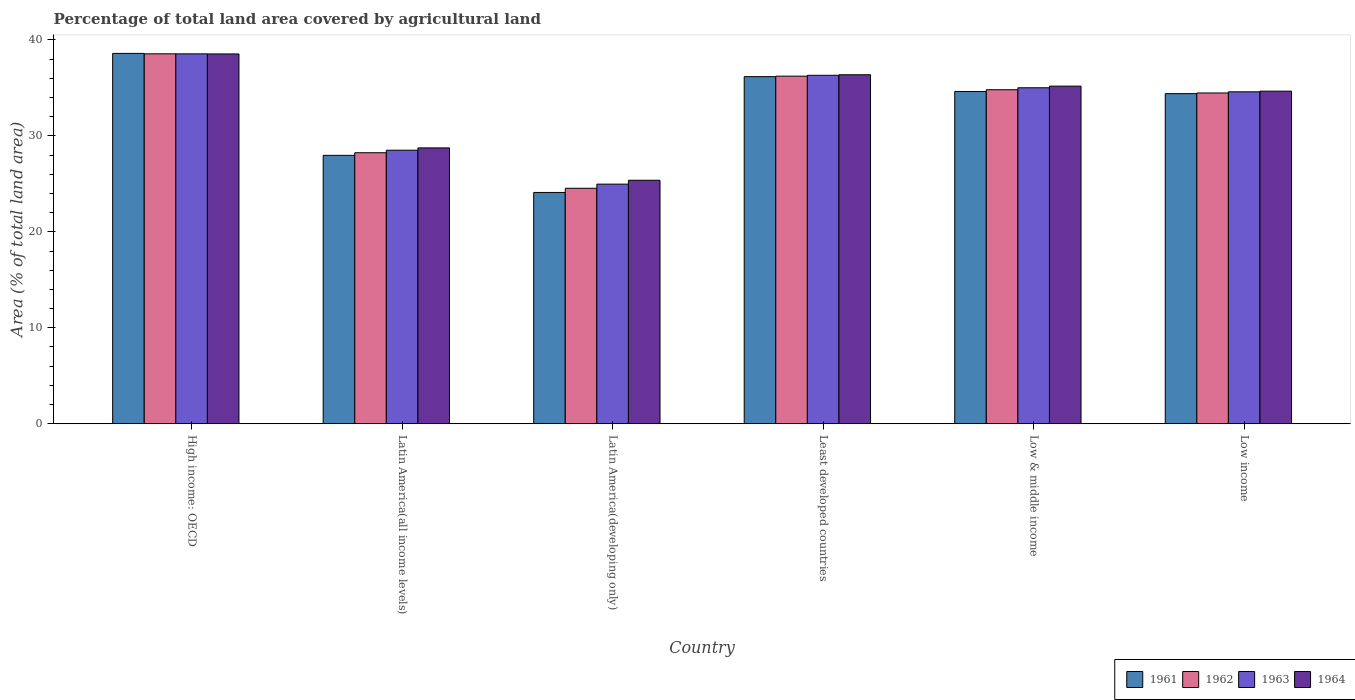Are the number of bars per tick equal to the number of legend labels?
Keep it short and to the point. Yes. Are the number of bars on each tick of the X-axis equal?
Keep it short and to the point. Yes. How many bars are there on the 1st tick from the left?
Provide a short and direct response. 4. How many bars are there on the 5th tick from the right?
Your answer should be compact. 4. What is the label of the 3rd group of bars from the left?
Offer a very short reply. Latin America(developing only). In how many cases, is the number of bars for a given country not equal to the number of legend labels?
Keep it short and to the point. 0. What is the percentage of agricultural land in 1962 in Low income?
Offer a terse response. 34.47. Across all countries, what is the maximum percentage of agricultural land in 1963?
Your answer should be compact. 38.54. Across all countries, what is the minimum percentage of agricultural land in 1964?
Provide a succinct answer. 25.37. In which country was the percentage of agricultural land in 1964 maximum?
Your response must be concise. High income: OECD. In which country was the percentage of agricultural land in 1963 minimum?
Your answer should be compact. Latin America(developing only). What is the total percentage of agricultural land in 1962 in the graph?
Provide a succinct answer. 196.82. What is the difference between the percentage of agricultural land in 1964 in Latin America(all income levels) and that in Low & middle income?
Provide a short and direct response. -6.44. What is the difference between the percentage of agricultural land in 1963 in Latin America(developing only) and the percentage of agricultural land in 1962 in High income: OECD?
Offer a terse response. -13.58. What is the average percentage of agricultural land in 1964 per country?
Make the answer very short. 33.14. What is the difference between the percentage of agricultural land of/in 1964 and percentage of agricultural land of/in 1962 in High income: OECD?
Offer a very short reply. -0.01. What is the ratio of the percentage of agricultural land in 1963 in Latin America(developing only) to that in Low & middle income?
Give a very brief answer. 0.71. Is the percentage of agricultural land in 1964 in High income: OECD less than that in Latin America(developing only)?
Make the answer very short. No. What is the difference between the highest and the second highest percentage of agricultural land in 1964?
Your answer should be very brief. -1.18. What is the difference between the highest and the lowest percentage of agricultural land in 1962?
Your answer should be compact. 14.01. In how many countries, is the percentage of agricultural land in 1961 greater than the average percentage of agricultural land in 1961 taken over all countries?
Offer a terse response. 4. What does the 1st bar from the left in High income: OECD represents?
Ensure brevity in your answer.  1961. What does the 3rd bar from the right in Low & middle income represents?
Your answer should be compact. 1962. How many countries are there in the graph?
Give a very brief answer. 6. Are the values on the major ticks of Y-axis written in scientific E-notation?
Keep it short and to the point. No. Does the graph contain any zero values?
Your answer should be compact. No. Where does the legend appear in the graph?
Your response must be concise. Bottom right. How are the legend labels stacked?
Provide a succinct answer. Horizontal. What is the title of the graph?
Provide a short and direct response. Percentage of total land area covered by agricultural land. What is the label or title of the X-axis?
Your response must be concise. Country. What is the label or title of the Y-axis?
Make the answer very short. Area (% of total land area). What is the Area (% of total land area) of 1961 in High income: OECD?
Offer a very short reply. 38.59. What is the Area (% of total land area) of 1962 in High income: OECD?
Your response must be concise. 38.55. What is the Area (% of total land area) in 1963 in High income: OECD?
Offer a very short reply. 38.54. What is the Area (% of total land area) in 1964 in High income: OECD?
Make the answer very short. 38.53. What is the Area (% of total land area) of 1961 in Latin America(all income levels)?
Ensure brevity in your answer.  27.97. What is the Area (% of total land area) in 1962 in Latin America(all income levels)?
Provide a succinct answer. 28.24. What is the Area (% of total land area) in 1963 in Latin America(all income levels)?
Your answer should be very brief. 28.5. What is the Area (% of total land area) in 1964 in Latin America(all income levels)?
Ensure brevity in your answer.  28.74. What is the Area (% of total land area) of 1961 in Latin America(developing only)?
Make the answer very short. 24.1. What is the Area (% of total land area) of 1962 in Latin America(developing only)?
Your answer should be compact. 24.54. What is the Area (% of total land area) of 1963 in Latin America(developing only)?
Offer a terse response. 24.97. What is the Area (% of total land area) in 1964 in Latin America(developing only)?
Provide a short and direct response. 25.37. What is the Area (% of total land area) of 1961 in Least developed countries?
Make the answer very short. 36.17. What is the Area (% of total land area) of 1962 in Least developed countries?
Offer a terse response. 36.22. What is the Area (% of total land area) in 1963 in Least developed countries?
Provide a succinct answer. 36.31. What is the Area (% of total land area) of 1964 in Least developed countries?
Provide a succinct answer. 36.37. What is the Area (% of total land area) of 1961 in Low & middle income?
Ensure brevity in your answer.  34.62. What is the Area (% of total land area) in 1962 in Low & middle income?
Offer a very short reply. 34.81. What is the Area (% of total land area) in 1963 in Low & middle income?
Provide a short and direct response. 35.01. What is the Area (% of total land area) of 1964 in Low & middle income?
Provide a succinct answer. 35.18. What is the Area (% of total land area) in 1961 in Low income?
Provide a short and direct response. 34.4. What is the Area (% of total land area) in 1962 in Low income?
Keep it short and to the point. 34.47. What is the Area (% of total land area) of 1963 in Low income?
Keep it short and to the point. 34.59. What is the Area (% of total land area) in 1964 in Low income?
Keep it short and to the point. 34.66. Across all countries, what is the maximum Area (% of total land area) in 1961?
Offer a very short reply. 38.59. Across all countries, what is the maximum Area (% of total land area) in 1962?
Give a very brief answer. 38.55. Across all countries, what is the maximum Area (% of total land area) in 1963?
Provide a succinct answer. 38.54. Across all countries, what is the maximum Area (% of total land area) in 1964?
Provide a short and direct response. 38.53. Across all countries, what is the minimum Area (% of total land area) of 1961?
Your answer should be compact. 24.1. Across all countries, what is the minimum Area (% of total land area) of 1962?
Your response must be concise. 24.54. Across all countries, what is the minimum Area (% of total land area) in 1963?
Offer a very short reply. 24.97. Across all countries, what is the minimum Area (% of total land area) of 1964?
Your response must be concise. 25.37. What is the total Area (% of total land area) in 1961 in the graph?
Provide a short and direct response. 195.85. What is the total Area (% of total land area) of 1962 in the graph?
Your answer should be compact. 196.82. What is the total Area (% of total land area) in 1963 in the graph?
Offer a terse response. 197.92. What is the total Area (% of total land area) of 1964 in the graph?
Make the answer very short. 198.85. What is the difference between the Area (% of total land area) of 1961 in High income: OECD and that in Latin America(all income levels)?
Make the answer very short. 10.62. What is the difference between the Area (% of total land area) of 1962 in High income: OECD and that in Latin America(all income levels)?
Ensure brevity in your answer.  10.31. What is the difference between the Area (% of total land area) of 1963 in High income: OECD and that in Latin America(all income levels)?
Provide a short and direct response. 10.04. What is the difference between the Area (% of total land area) of 1964 in High income: OECD and that in Latin America(all income levels)?
Offer a very short reply. 9.79. What is the difference between the Area (% of total land area) of 1961 in High income: OECD and that in Latin America(developing only)?
Provide a succinct answer. 14.49. What is the difference between the Area (% of total land area) in 1962 in High income: OECD and that in Latin America(developing only)?
Ensure brevity in your answer.  14.01. What is the difference between the Area (% of total land area) of 1963 in High income: OECD and that in Latin America(developing only)?
Your answer should be compact. 13.58. What is the difference between the Area (% of total land area) of 1964 in High income: OECD and that in Latin America(developing only)?
Make the answer very short. 13.16. What is the difference between the Area (% of total land area) in 1961 in High income: OECD and that in Least developed countries?
Keep it short and to the point. 2.42. What is the difference between the Area (% of total land area) of 1962 in High income: OECD and that in Least developed countries?
Your answer should be compact. 2.33. What is the difference between the Area (% of total land area) of 1963 in High income: OECD and that in Least developed countries?
Your answer should be very brief. 2.23. What is the difference between the Area (% of total land area) in 1964 in High income: OECD and that in Least developed countries?
Give a very brief answer. 2.17. What is the difference between the Area (% of total land area) in 1961 in High income: OECD and that in Low & middle income?
Give a very brief answer. 3.97. What is the difference between the Area (% of total land area) in 1962 in High income: OECD and that in Low & middle income?
Your response must be concise. 3.74. What is the difference between the Area (% of total land area) of 1963 in High income: OECD and that in Low & middle income?
Provide a succinct answer. 3.53. What is the difference between the Area (% of total land area) in 1964 in High income: OECD and that in Low & middle income?
Offer a very short reply. 3.35. What is the difference between the Area (% of total land area) of 1961 in High income: OECD and that in Low income?
Make the answer very short. 4.19. What is the difference between the Area (% of total land area) of 1962 in High income: OECD and that in Low income?
Make the answer very short. 4.08. What is the difference between the Area (% of total land area) in 1963 in High income: OECD and that in Low income?
Provide a short and direct response. 3.96. What is the difference between the Area (% of total land area) of 1964 in High income: OECD and that in Low income?
Your response must be concise. 3.88. What is the difference between the Area (% of total land area) of 1961 in Latin America(all income levels) and that in Latin America(developing only)?
Offer a terse response. 3.87. What is the difference between the Area (% of total land area) of 1962 in Latin America(all income levels) and that in Latin America(developing only)?
Your answer should be compact. 3.7. What is the difference between the Area (% of total land area) of 1963 in Latin America(all income levels) and that in Latin America(developing only)?
Your response must be concise. 3.53. What is the difference between the Area (% of total land area) of 1964 in Latin America(all income levels) and that in Latin America(developing only)?
Make the answer very short. 3.37. What is the difference between the Area (% of total land area) of 1961 in Latin America(all income levels) and that in Least developed countries?
Give a very brief answer. -8.2. What is the difference between the Area (% of total land area) of 1962 in Latin America(all income levels) and that in Least developed countries?
Your answer should be very brief. -7.98. What is the difference between the Area (% of total land area) of 1963 in Latin America(all income levels) and that in Least developed countries?
Your response must be concise. -7.81. What is the difference between the Area (% of total land area) of 1964 in Latin America(all income levels) and that in Least developed countries?
Provide a succinct answer. -7.62. What is the difference between the Area (% of total land area) in 1961 in Latin America(all income levels) and that in Low & middle income?
Provide a short and direct response. -6.66. What is the difference between the Area (% of total land area) in 1962 in Latin America(all income levels) and that in Low & middle income?
Your answer should be very brief. -6.57. What is the difference between the Area (% of total land area) of 1963 in Latin America(all income levels) and that in Low & middle income?
Offer a very short reply. -6.51. What is the difference between the Area (% of total land area) of 1964 in Latin America(all income levels) and that in Low & middle income?
Provide a succinct answer. -6.44. What is the difference between the Area (% of total land area) of 1961 in Latin America(all income levels) and that in Low income?
Your answer should be very brief. -6.43. What is the difference between the Area (% of total land area) in 1962 in Latin America(all income levels) and that in Low income?
Provide a succinct answer. -6.23. What is the difference between the Area (% of total land area) in 1963 in Latin America(all income levels) and that in Low income?
Provide a succinct answer. -6.08. What is the difference between the Area (% of total land area) in 1964 in Latin America(all income levels) and that in Low income?
Offer a very short reply. -5.91. What is the difference between the Area (% of total land area) in 1961 in Latin America(developing only) and that in Least developed countries?
Provide a succinct answer. -12.07. What is the difference between the Area (% of total land area) of 1962 in Latin America(developing only) and that in Least developed countries?
Provide a succinct answer. -11.68. What is the difference between the Area (% of total land area) in 1963 in Latin America(developing only) and that in Least developed countries?
Keep it short and to the point. -11.34. What is the difference between the Area (% of total land area) in 1964 in Latin America(developing only) and that in Least developed countries?
Make the answer very short. -10.99. What is the difference between the Area (% of total land area) in 1961 in Latin America(developing only) and that in Low & middle income?
Your answer should be very brief. -10.52. What is the difference between the Area (% of total land area) of 1962 in Latin America(developing only) and that in Low & middle income?
Give a very brief answer. -10.27. What is the difference between the Area (% of total land area) of 1963 in Latin America(developing only) and that in Low & middle income?
Your answer should be compact. -10.04. What is the difference between the Area (% of total land area) of 1964 in Latin America(developing only) and that in Low & middle income?
Offer a very short reply. -9.81. What is the difference between the Area (% of total land area) of 1961 in Latin America(developing only) and that in Low income?
Ensure brevity in your answer.  -10.3. What is the difference between the Area (% of total land area) of 1962 in Latin America(developing only) and that in Low income?
Your response must be concise. -9.93. What is the difference between the Area (% of total land area) in 1963 in Latin America(developing only) and that in Low income?
Offer a terse response. -9.62. What is the difference between the Area (% of total land area) in 1964 in Latin America(developing only) and that in Low income?
Offer a terse response. -9.28. What is the difference between the Area (% of total land area) of 1961 in Least developed countries and that in Low & middle income?
Your response must be concise. 1.54. What is the difference between the Area (% of total land area) of 1962 in Least developed countries and that in Low & middle income?
Give a very brief answer. 1.42. What is the difference between the Area (% of total land area) in 1963 in Least developed countries and that in Low & middle income?
Make the answer very short. 1.3. What is the difference between the Area (% of total land area) of 1964 in Least developed countries and that in Low & middle income?
Ensure brevity in your answer.  1.19. What is the difference between the Area (% of total land area) of 1961 in Least developed countries and that in Low income?
Provide a short and direct response. 1.77. What is the difference between the Area (% of total land area) of 1962 in Least developed countries and that in Low income?
Provide a short and direct response. 1.75. What is the difference between the Area (% of total land area) in 1963 in Least developed countries and that in Low income?
Make the answer very short. 1.72. What is the difference between the Area (% of total land area) in 1964 in Least developed countries and that in Low income?
Your answer should be compact. 1.71. What is the difference between the Area (% of total land area) of 1961 in Low & middle income and that in Low income?
Offer a terse response. 0.22. What is the difference between the Area (% of total land area) in 1962 in Low & middle income and that in Low income?
Provide a short and direct response. 0.34. What is the difference between the Area (% of total land area) of 1963 in Low & middle income and that in Low income?
Provide a short and direct response. 0.42. What is the difference between the Area (% of total land area) of 1964 in Low & middle income and that in Low income?
Offer a terse response. 0.53. What is the difference between the Area (% of total land area) of 1961 in High income: OECD and the Area (% of total land area) of 1962 in Latin America(all income levels)?
Your answer should be very brief. 10.35. What is the difference between the Area (% of total land area) of 1961 in High income: OECD and the Area (% of total land area) of 1963 in Latin America(all income levels)?
Provide a succinct answer. 10.09. What is the difference between the Area (% of total land area) of 1961 in High income: OECD and the Area (% of total land area) of 1964 in Latin America(all income levels)?
Offer a terse response. 9.85. What is the difference between the Area (% of total land area) of 1962 in High income: OECD and the Area (% of total land area) of 1963 in Latin America(all income levels)?
Keep it short and to the point. 10.04. What is the difference between the Area (% of total land area) of 1962 in High income: OECD and the Area (% of total land area) of 1964 in Latin America(all income levels)?
Offer a terse response. 9.8. What is the difference between the Area (% of total land area) in 1963 in High income: OECD and the Area (% of total land area) in 1964 in Latin America(all income levels)?
Your answer should be compact. 9.8. What is the difference between the Area (% of total land area) of 1961 in High income: OECD and the Area (% of total land area) of 1962 in Latin America(developing only)?
Your answer should be compact. 14.06. What is the difference between the Area (% of total land area) of 1961 in High income: OECD and the Area (% of total land area) of 1963 in Latin America(developing only)?
Your response must be concise. 13.62. What is the difference between the Area (% of total land area) in 1961 in High income: OECD and the Area (% of total land area) in 1964 in Latin America(developing only)?
Keep it short and to the point. 13.22. What is the difference between the Area (% of total land area) in 1962 in High income: OECD and the Area (% of total land area) in 1963 in Latin America(developing only)?
Provide a short and direct response. 13.58. What is the difference between the Area (% of total land area) of 1962 in High income: OECD and the Area (% of total land area) of 1964 in Latin America(developing only)?
Offer a terse response. 13.17. What is the difference between the Area (% of total land area) in 1963 in High income: OECD and the Area (% of total land area) in 1964 in Latin America(developing only)?
Ensure brevity in your answer.  13.17. What is the difference between the Area (% of total land area) in 1961 in High income: OECD and the Area (% of total land area) in 1962 in Least developed countries?
Offer a very short reply. 2.37. What is the difference between the Area (% of total land area) in 1961 in High income: OECD and the Area (% of total land area) in 1963 in Least developed countries?
Your answer should be very brief. 2.28. What is the difference between the Area (% of total land area) in 1961 in High income: OECD and the Area (% of total land area) in 1964 in Least developed countries?
Ensure brevity in your answer.  2.23. What is the difference between the Area (% of total land area) in 1962 in High income: OECD and the Area (% of total land area) in 1963 in Least developed countries?
Provide a succinct answer. 2.24. What is the difference between the Area (% of total land area) in 1962 in High income: OECD and the Area (% of total land area) in 1964 in Least developed countries?
Ensure brevity in your answer.  2.18. What is the difference between the Area (% of total land area) of 1963 in High income: OECD and the Area (% of total land area) of 1964 in Least developed countries?
Provide a short and direct response. 2.18. What is the difference between the Area (% of total land area) of 1961 in High income: OECD and the Area (% of total land area) of 1962 in Low & middle income?
Your answer should be very brief. 3.79. What is the difference between the Area (% of total land area) in 1961 in High income: OECD and the Area (% of total land area) in 1963 in Low & middle income?
Offer a very short reply. 3.58. What is the difference between the Area (% of total land area) of 1961 in High income: OECD and the Area (% of total land area) of 1964 in Low & middle income?
Provide a succinct answer. 3.41. What is the difference between the Area (% of total land area) of 1962 in High income: OECD and the Area (% of total land area) of 1963 in Low & middle income?
Provide a succinct answer. 3.54. What is the difference between the Area (% of total land area) of 1962 in High income: OECD and the Area (% of total land area) of 1964 in Low & middle income?
Keep it short and to the point. 3.37. What is the difference between the Area (% of total land area) in 1963 in High income: OECD and the Area (% of total land area) in 1964 in Low & middle income?
Provide a succinct answer. 3.36. What is the difference between the Area (% of total land area) in 1961 in High income: OECD and the Area (% of total land area) in 1962 in Low income?
Make the answer very short. 4.13. What is the difference between the Area (% of total land area) in 1961 in High income: OECD and the Area (% of total land area) in 1963 in Low income?
Ensure brevity in your answer.  4. What is the difference between the Area (% of total land area) of 1961 in High income: OECD and the Area (% of total land area) of 1964 in Low income?
Keep it short and to the point. 3.94. What is the difference between the Area (% of total land area) of 1962 in High income: OECD and the Area (% of total land area) of 1963 in Low income?
Provide a short and direct response. 3.96. What is the difference between the Area (% of total land area) in 1962 in High income: OECD and the Area (% of total land area) in 1964 in Low income?
Offer a very short reply. 3.89. What is the difference between the Area (% of total land area) in 1963 in High income: OECD and the Area (% of total land area) in 1964 in Low income?
Offer a terse response. 3.89. What is the difference between the Area (% of total land area) in 1961 in Latin America(all income levels) and the Area (% of total land area) in 1962 in Latin America(developing only)?
Your answer should be compact. 3.43. What is the difference between the Area (% of total land area) of 1961 in Latin America(all income levels) and the Area (% of total land area) of 1963 in Latin America(developing only)?
Offer a very short reply. 3. What is the difference between the Area (% of total land area) in 1961 in Latin America(all income levels) and the Area (% of total land area) in 1964 in Latin America(developing only)?
Your answer should be very brief. 2.6. What is the difference between the Area (% of total land area) of 1962 in Latin America(all income levels) and the Area (% of total land area) of 1963 in Latin America(developing only)?
Your answer should be very brief. 3.27. What is the difference between the Area (% of total land area) in 1962 in Latin America(all income levels) and the Area (% of total land area) in 1964 in Latin America(developing only)?
Provide a short and direct response. 2.87. What is the difference between the Area (% of total land area) of 1963 in Latin America(all income levels) and the Area (% of total land area) of 1964 in Latin America(developing only)?
Keep it short and to the point. 3.13. What is the difference between the Area (% of total land area) in 1961 in Latin America(all income levels) and the Area (% of total land area) in 1962 in Least developed countries?
Provide a short and direct response. -8.25. What is the difference between the Area (% of total land area) in 1961 in Latin America(all income levels) and the Area (% of total land area) in 1963 in Least developed countries?
Offer a very short reply. -8.34. What is the difference between the Area (% of total land area) in 1961 in Latin America(all income levels) and the Area (% of total land area) in 1964 in Least developed countries?
Your response must be concise. -8.4. What is the difference between the Area (% of total land area) in 1962 in Latin America(all income levels) and the Area (% of total land area) in 1963 in Least developed countries?
Your response must be concise. -8.07. What is the difference between the Area (% of total land area) of 1962 in Latin America(all income levels) and the Area (% of total land area) of 1964 in Least developed countries?
Give a very brief answer. -8.13. What is the difference between the Area (% of total land area) in 1963 in Latin America(all income levels) and the Area (% of total land area) in 1964 in Least developed countries?
Ensure brevity in your answer.  -7.86. What is the difference between the Area (% of total land area) in 1961 in Latin America(all income levels) and the Area (% of total land area) in 1962 in Low & middle income?
Your response must be concise. -6.84. What is the difference between the Area (% of total land area) in 1961 in Latin America(all income levels) and the Area (% of total land area) in 1963 in Low & middle income?
Your answer should be compact. -7.04. What is the difference between the Area (% of total land area) in 1961 in Latin America(all income levels) and the Area (% of total land area) in 1964 in Low & middle income?
Keep it short and to the point. -7.21. What is the difference between the Area (% of total land area) in 1962 in Latin America(all income levels) and the Area (% of total land area) in 1963 in Low & middle income?
Offer a very short reply. -6.77. What is the difference between the Area (% of total land area) in 1962 in Latin America(all income levels) and the Area (% of total land area) in 1964 in Low & middle income?
Provide a short and direct response. -6.94. What is the difference between the Area (% of total land area) of 1963 in Latin America(all income levels) and the Area (% of total land area) of 1964 in Low & middle income?
Ensure brevity in your answer.  -6.68. What is the difference between the Area (% of total land area) of 1961 in Latin America(all income levels) and the Area (% of total land area) of 1962 in Low income?
Provide a succinct answer. -6.5. What is the difference between the Area (% of total land area) in 1961 in Latin America(all income levels) and the Area (% of total land area) in 1963 in Low income?
Offer a terse response. -6.62. What is the difference between the Area (% of total land area) of 1961 in Latin America(all income levels) and the Area (% of total land area) of 1964 in Low income?
Your answer should be very brief. -6.69. What is the difference between the Area (% of total land area) in 1962 in Latin America(all income levels) and the Area (% of total land area) in 1963 in Low income?
Your response must be concise. -6.35. What is the difference between the Area (% of total land area) in 1962 in Latin America(all income levels) and the Area (% of total land area) in 1964 in Low income?
Offer a terse response. -6.42. What is the difference between the Area (% of total land area) in 1963 in Latin America(all income levels) and the Area (% of total land area) in 1964 in Low income?
Provide a succinct answer. -6.15. What is the difference between the Area (% of total land area) of 1961 in Latin America(developing only) and the Area (% of total land area) of 1962 in Least developed countries?
Offer a very short reply. -12.12. What is the difference between the Area (% of total land area) in 1961 in Latin America(developing only) and the Area (% of total land area) in 1963 in Least developed countries?
Your answer should be compact. -12.21. What is the difference between the Area (% of total land area) in 1961 in Latin America(developing only) and the Area (% of total land area) in 1964 in Least developed countries?
Your response must be concise. -12.26. What is the difference between the Area (% of total land area) of 1962 in Latin America(developing only) and the Area (% of total land area) of 1963 in Least developed countries?
Your answer should be compact. -11.77. What is the difference between the Area (% of total land area) of 1962 in Latin America(developing only) and the Area (% of total land area) of 1964 in Least developed countries?
Your response must be concise. -11.83. What is the difference between the Area (% of total land area) in 1963 in Latin America(developing only) and the Area (% of total land area) in 1964 in Least developed countries?
Your response must be concise. -11.4. What is the difference between the Area (% of total land area) of 1961 in Latin America(developing only) and the Area (% of total land area) of 1962 in Low & middle income?
Keep it short and to the point. -10.7. What is the difference between the Area (% of total land area) of 1961 in Latin America(developing only) and the Area (% of total land area) of 1963 in Low & middle income?
Your answer should be very brief. -10.91. What is the difference between the Area (% of total land area) in 1961 in Latin America(developing only) and the Area (% of total land area) in 1964 in Low & middle income?
Your answer should be very brief. -11.08. What is the difference between the Area (% of total land area) in 1962 in Latin America(developing only) and the Area (% of total land area) in 1963 in Low & middle income?
Ensure brevity in your answer.  -10.47. What is the difference between the Area (% of total land area) in 1962 in Latin America(developing only) and the Area (% of total land area) in 1964 in Low & middle income?
Make the answer very short. -10.64. What is the difference between the Area (% of total land area) in 1963 in Latin America(developing only) and the Area (% of total land area) in 1964 in Low & middle income?
Make the answer very short. -10.21. What is the difference between the Area (% of total land area) of 1961 in Latin America(developing only) and the Area (% of total land area) of 1962 in Low income?
Your answer should be very brief. -10.36. What is the difference between the Area (% of total land area) in 1961 in Latin America(developing only) and the Area (% of total land area) in 1963 in Low income?
Ensure brevity in your answer.  -10.48. What is the difference between the Area (% of total land area) of 1961 in Latin America(developing only) and the Area (% of total land area) of 1964 in Low income?
Ensure brevity in your answer.  -10.55. What is the difference between the Area (% of total land area) of 1962 in Latin America(developing only) and the Area (% of total land area) of 1963 in Low income?
Your answer should be compact. -10.05. What is the difference between the Area (% of total land area) in 1962 in Latin America(developing only) and the Area (% of total land area) in 1964 in Low income?
Give a very brief answer. -10.12. What is the difference between the Area (% of total land area) in 1963 in Latin America(developing only) and the Area (% of total land area) in 1964 in Low income?
Your answer should be very brief. -9.69. What is the difference between the Area (% of total land area) in 1961 in Least developed countries and the Area (% of total land area) in 1962 in Low & middle income?
Provide a short and direct response. 1.36. What is the difference between the Area (% of total land area) of 1961 in Least developed countries and the Area (% of total land area) of 1963 in Low & middle income?
Your answer should be very brief. 1.16. What is the difference between the Area (% of total land area) in 1961 in Least developed countries and the Area (% of total land area) in 1964 in Low & middle income?
Ensure brevity in your answer.  0.99. What is the difference between the Area (% of total land area) in 1962 in Least developed countries and the Area (% of total land area) in 1963 in Low & middle income?
Offer a terse response. 1.21. What is the difference between the Area (% of total land area) in 1962 in Least developed countries and the Area (% of total land area) in 1964 in Low & middle income?
Keep it short and to the point. 1.04. What is the difference between the Area (% of total land area) in 1963 in Least developed countries and the Area (% of total land area) in 1964 in Low & middle income?
Offer a terse response. 1.13. What is the difference between the Area (% of total land area) of 1961 in Least developed countries and the Area (% of total land area) of 1962 in Low income?
Your response must be concise. 1.7. What is the difference between the Area (% of total land area) of 1961 in Least developed countries and the Area (% of total land area) of 1963 in Low income?
Your answer should be compact. 1.58. What is the difference between the Area (% of total land area) of 1961 in Least developed countries and the Area (% of total land area) of 1964 in Low income?
Make the answer very short. 1.51. What is the difference between the Area (% of total land area) in 1962 in Least developed countries and the Area (% of total land area) in 1963 in Low income?
Keep it short and to the point. 1.63. What is the difference between the Area (% of total land area) in 1962 in Least developed countries and the Area (% of total land area) in 1964 in Low income?
Make the answer very short. 1.56. What is the difference between the Area (% of total land area) of 1963 in Least developed countries and the Area (% of total land area) of 1964 in Low income?
Your answer should be very brief. 1.65. What is the difference between the Area (% of total land area) in 1961 in Low & middle income and the Area (% of total land area) in 1962 in Low income?
Offer a terse response. 0.16. What is the difference between the Area (% of total land area) in 1961 in Low & middle income and the Area (% of total land area) in 1963 in Low income?
Provide a succinct answer. 0.04. What is the difference between the Area (% of total land area) in 1961 in Low & middle income and the Area (% of total land area) in 1964 in Low income?
Ensure brevity in your answer.  -0.03. What is the difference between the Area (% of total land area) in 1962 in Low & middle income and the Area (% of total land area) in 1963 in Low income?
Offer a terse response. 0.22. What is the difference between the Area (% of total land area) in 1962 in Low & middle income and the Area (% of total land area) in 1964 in Low income?
Ensure brevity in your answer.  0.15. What is the difference between the Area (% of total land area) of 1963 in Low & middle income and the Area (% of total land area) of 1964 in Low income?
Make the answer very short. 0.35. What is the average Area (% of total land area) in 1961 per country?
Your answer should be very brief. 32.64. What is the average Area (% of total land area) in 1962 per country?
Your answer should be compact. 32.8. What is the average Area (% of total land area) of 1963 per country?
Keep it short and to the point. 32.99. What is the average Area (% of total land area) in 1964 per country?
Make the answer very short. 33.14. What is the difference between the Area (% of total land area) of 1961 and Area (% of total land area) of 1962 in High income: OECD?
Your response must be concise. 0.04. What is the difference between the Area (% of total land area) in 1961 and Area (% of total land area) in 1963 in High income: OECD?
Your answer should be very brief. 0.05. What is the difference between the Area (% of total land area) of 1961 and Area (% of total land area) of 1964 in High income: OECD?
Your response must be concise. 0.06. What is the difference between the Area (% of total land area) of 1962 and Area (% of total land area) of 1963 in High income: OECD?
Offer a very short reply. 0. What is the difference between the Area (% of total land area) in 1962 and Area (% of total land area) in 1964 in High income: OECD?
Offer a very short reply. 0.01. What is the difference between the Area (% of total land area) in 1963 and Area (% of total land area) in 1964 in High income: OECD?
Offer a terse response. 0.01. What is the difference between the Area (% of total land area) of 1961 and Area (% of total land area) of 1962 in Latin America(all income levels)?
Your answer should be very brief. -0.27. What is the difference between the Area (% of total land area) in 1961 and Area (% of total land area) in 1963 in Latin America(all income levels)?
Provide a succinct answer. -0.54. What is the difference between the Area (% of total land area) of 1961 and Area (% of total land area) of 1964 in Latin America(all income levels)?
Keep it short and to the point. -0.78. What is the difference between the Area (% of total land area) of 1962 and Area (% of total land area) of 1963 in Latin America(all income levels)?
Provide a short and direct response. -0.26. What is the difference between the Area (% of total land area) in 1962 and Area (% of total land area) in 1964 in Latin America(all income levels)?
Your answer should be compact. -0.51. What is the difference between the Area (% of total land area) of 1963 and Area (% of total land area) of 1964 in Latin America(all income levels)?
Your answer should be very brief. -0.24. What is the difference between the Area (% of total land area) in 1961 and Area (% of total land area) in 1962 in Latin America(developing only)?
Keep it short and to the point. -0.43. What is the difference between the Area (% of total land area) of 1961 and Area (% of total land area) of 1963 in Latin America(developing only)?
Your answer should be very brief. -0.87. What is the difference between the Area (% of total land area) of 1961 and Area (% of total land area) of 1964 in Latin America(developing only)?
Offer a terse response. -1.27. What is the difference between the Area (% of total land area) of 1962 and Area (% of total land area) of 1963 in Latin America(developing only)?
Provide a short and direct response. -0.43. What is the difference between the Area (% of total land area) of 1962 and Area (% of total land area) of 1964 in Latin America(developing only)?
Your answer should be very brief. -0.84. What is the difference between the Area (% of total land area) in 1963 and Area (% of total land area) in 1964 in Latin America(developing only)?
Provide a succinct answer. -0.4. What is the difference between the Area (% of total land area) of 1961 and Area (% of total land area) of 1962 in Least developed countries?
Give a very brief answer. -0.05. What is the difference between the Area (% of total land area) of 1961 and Area (% of total land area) of 1963 in Least developed countries?
Make the answer very short. -0.14. What is the difference between the Area (% of total land area) of 1961 and Area (% of total land area) of 1964 in Least developed countries?
Your answer should be compact. -0.2. What is the difference between the Area (% of total land area) in 1962 and Area (% of total land area) in 1963 in Least developed countries?
Your answer should be compact. -0.09. What is the difference between the Area (% of total land area) of 1962 and Area (% of total land area) of 1964 in Least developed countries?
Your response must be concise. -0.15. What is the difference between the Area (% of total land area) of 1963 and Area (% of total land area) of 1964 in Least developed countries?
Your response must be concise. -0.06. What is the difference between the Area (% of total land area) in 1961 and Area (% of total land area) in 1962 in Low & middle income?
Provide a succinct answer. -0.18. What is the difference between the Area (% of total land area) of 1961 and Area (% of total land area) of 1963 in Low & middle income?
Your answer should be compact. -0.39. What is the difference between the Area (% of total land area) of 1961 and Area (% of total land area) of 1964 in Low & middle income?
Make the answer very short. -0.56. What is the difference between the Area (% of total land area) of 1962 and Area (% of total land area) of 1963 in Low & middle income?
Provide a short and direct response. -0.2. What is the difference between the Area (% of total land area) in 1962 and Area (% of total land area) in 1964 in Low & middle income?
Your answer should be very brief. -0.38. What is the difference between the Area (% of total land area) in 1963 and Area (% of total land area) in 1964 in Low & middle income?
Your answer should be compact. -0.17. What is the difference between the Area (% of total land area) in 1961 and Area (% of total land area) in 1962 in Low income?
Offer a very short reply. -0.07. What is the difference between the Area (% of total land area) of 1961 and Area (% of total land area) of 1963 in Low income?
Your answer should be very brief. -0.19. What is the difference between the Area (% of total land area) in 1961 and Area (% of total land area) in 1964 in Low income?
Offer a terse response. -0.26. What is the difference between the Area (% of total land area) in 1962 and Area (% of total land area) in 1963 in Low income?
Your response must be concise. -0.12. What is the difference between the Area (% of total land area) in 1962 and Area (% of total land area) in 1964 in Low income?
Your response must be concise. -0.19. What is the difference between the Area (% of total land area) of 1963 and Area (% of total land area) of 1964 in Low income?
Offer a very short reply. -0.07. What is the ratio of the Area (% of total land area) in 1961 in High income: OECD to that in Latin America(all income levels)?
Make the answer very short. 1.38. What is the ratio of the Area (% of total land area) in 1962 in High income: OECD to that in Latin America(all income levels)?
Offer a very short reply. 1.36. What is the ratio of the Area (% of total land area) in 1963 in High income: OECD to that in Latin America(all income levels)?
Your answer should be very brief. 1.35. What is the ratio of the Area (% of total land area) of 1964 in High income: OECD to that in Latin America(all income levels)?
Your response must be concise. 1.34. What is the ratio of the Area (% of total land area) of 1961 in High income: OECD to that in Latin America(developing only)?
Your response must be concise. 1.6. What is the ratio of the Area (% of total land area) of 1962 in High income: OECD to that in Latin America(developing only)?
Make the answer very short. 1.57. What is the ratio of the Area (% of total land area) in 1963 in High income: OECD to that in Latin America(developing only)?
Offer a very short reply. 1.54. What is the ratio of the Area (% of total land area) of 1964 in High income: OECD to that in Latin America(developing only)?
Give a very brief answer. 1.52. What is the ratio of the Area (% of total land area) of 1961 in High income: OECD to that in Least developed countries?
Offer a very short reply. 1.07. What is the ratio of the Area (% of total land area) of 1962 in High income: OECD to that in Least developed countries?
Offer a very short reply. 1.06. What is the ratio of the Area (% of total land area) in 1963 in High income: OECD to that in Least developed countries?
Offer a terse response. 1.06. What is the ratio of the Area (% of total land area) of 1964 in High income: OECD to that in Least developed countries?
Your response must be concise. 1.06. What is the ratio of the Area (% of total land area) in 1961 in High income: OECD to that in Low & middle income?
Keep it short and to the point. 1.11. What is the ratio of the Area (% of total land area) in 1962 in High income: OECD to that in Low & middle income?
Give a very brief answer. 1.11. What is the ratio of the Area (% of total land area) in 1963 in High income: OECD to that in Low & middle income?
Provide a short and direct response. 1.1. What is the ratio of the Area (% of total land area) of 1964 in High income: OECD to that in Low & middle income?
Provide a succinct answer. 1.1. What is the ratio of the Area (% of total land area) of 1961 in High income: OECD to that in Low income?
Give a very brief answer. 1.12. What is the ratio of the Area (% of total land area) of 1962 in High income: OECD to that in Low income?
Offer a very short reply. 1.12. What is the ratio of the Area (% of total land area) of 1963 in High income: OECD to that in Low income?
Your answer should be very brief. 1.11. What is the ratio of the Area (% of total land area) of 1964 in High income: OECD to that in Low income?
Make the answer very short. 1.11. What is the ratio of the Area (% of total land area) in 1961 in Latin America(all income levels) to that in Latin America(developing only)?
Make the answer very short. 1.16. What is the ratio of the Area (% of total land area) in 1962 in Latin America(all income levels) to that in Latin America(developing only)?
Keep it short and to the point. 1.15. What is the ratio of the Area (% of total land area) of 1963 in Latin America(all income levels) to that in Latin America(developing only)?
Offer a terse response. 1.14. What is the ratio of the Area (% of total land area) of 1964 in Latin America(all income levels) to that in Latin America(developing only)?
Ensure brevity in your answer.  1.13. What is the ratio of the Area (% of total land area) in 1961 in Latin America(all income levels) to that in Least developed countries?
Keep it short and to the point. 0.77. What is the ratio of the Area (% of total land area) in 1962 in Latin America(all income levels) to that in Least developed countries?
Offer a very short reply. 0.78. What is the ratio of the Area (% of total land area) of 1963 in Latin America(all income levels) to that in Least developed countries?
Provide a succinct answer. 0.79. What is the ratio of the Area (% of total land area) in 1964 in Latin America(all income levels) to that in Least developed countries?
Your answer should be compact. 0.79. What is the ratio of the Area (% of total land area) of 1961 in Latin America(all income levels) to that in Low & middle income?
Give a very brief answer. 0.81. What is the ratio of the Area (% of total land area) of 1962 in Latin America(all income levels) to that in Low & middle income?
Your response must be concise. 0.81. What is the ratio of the Area (% of total land area) of 1963 in Latin America(all income levels) to that in Low & middle income?
Offer a terse response. 0.81. What is the ratio of the Area (% of total land area) of 1964 in Latin America(all income levels) to that in Low & middle income?
Provide a short and direct response. 0.82. What is the ratio of the Area (% of total land area) in 1961 in Latin America(all income levels) to that in Low income?
Provide a short and direct response. 0.81. What is the ratio of the Area (% of total land area) in 1962 in Latin America(all income levels) to that in Low income?
Keep it short and to the point. 0.82. What is the ratio of the Area (% of total land area) of 1963 in Latin America(all income levels) to that in Low income?
Your answer should be compact. 0.82. What is the ratio of the Area (% of total land area) of 1964 in Latin America(all income levels) to that in Low income?
Make the answer very short. 0.83. What is the ratio of the Area (% of total land area) of 1961 in Latin America(developing only) to that in Least developed countries?
Make the answer very short. 0.67. What is the ratio of the Area (% of total land area) of 1962 in Latin America(developing only) to that in Least developed countries?
Keep it short and to the point. 0.68. What is the ratio of the Area (% of total land area) of 1963 in Latin America(developing only) to that in Least developed countries?
Ensure brevity in your answer.  0.69. What is the ratio of the Area (% of total land area) in 1964 in Latin America(developing only) to that in Least developed countries?
Offer a terse response. 0.7. What is the ratio of the Area (% of total land area) in 1961 in Latin America(developing only) to that in Low & middle income?
Keep it short and to the point. 0.7. What is the ratio of the Area (% of total land area) of 1962 in Latin America(developing only) to that in Low & middle income?
Give a very brief answer. 0.7. What is the ratio of the Area (% of total land area) in 1963 in Latin America(developing only) to that in Low & middle income?
Your answer should be compact. 0.71. What is the ratio of the Area (% of total land area) in 1964 in Latin America(developing only) to that in Low & middle income?
Ensure brevity in your answer.  0.72. What is the ratio of the Area (% of total land area) of 1961 in Latin America(developing only) to that in Low income?
Offer a very short reply. 0.7. What is the ratio of the Area (% of total land area) in 1962 in Latin America(developing only) to that in Low income?
Your answer should be compact. 0.71. What is the ratio of the Area (% of total land area) in 1963 in Latin America(developing only) to that in Low income?
Your answer should be very brief. 0.72. What is the ratio of the Area (% of total land area) in 1964 in Latin America(developing only) to that in Low income?
Provide a succinct answer. 0.73. What is the ratio of the Area (% of total land area) in 1961 in Least developed countries to that in Low & middle income?
Give a very brief answer. 1.04. What is the ratio of the Area (% of total land area) of 1962 in Least developed countries to that in Low & middle income?
Your answer should be very brief. 1.04. What is the ratio of the Area (% of total land area) of 1963 in Least developed countries to that in Low & middle income?
Your response must be concise. 1.04. What is the ratio of the Area (% of total land area) of 1964 in Least developed countries to that in Low & middle income?
Keep it short and to the point. 1.03. What is the ratio of the Area (% of total land area) in 1961 in Least developed countries to that in Low income?
Keep it short and to the point. 1.05. What is the ratio of the Area (% of total land area) of 1962 in Least developed countries to that in Low income?
Provide a succinct answer. 1.05. What is the ratio of the Area (% of total land area) in 1963 in Least developed countries to that in Low income?
Your answer should be very brief. 1.05. What is the ratio of the Area (% of total land area) of 1964 in Least developed countries to that in Low income?
Your answer should be compact. 1.05. What is the ratio of the Area (% of total land area) in 1961 in Low & middle income to that in Low income?
Make the answer very short. 1.01. What is the ratio of the Area (% of total land area) in 1962 in Low & middle income to that in Low income?
Provide a short and direct response. 1.01. What is the ratio of the Area (% of total land area) in 1963 in Low & middle income to that in Low income?
Make the answer very short. 1.01. What is the ratio of the Area (% of total land area) of 1964 in Low & middle income to that in Low income?
Ensure brevity in your answer.  1.02. What is the difference between the highest and the second highest Area (% of total land area) of 1961?
Provide a succinct answer. 2.42. What is the difference between the highest and the second highest Area (% of total land area) of 1962?
Your response must be concise. 2.33. What is the difference between the highest and the second highest Area (% of total land area) of 1963?
Your answer should be compact. 2.23. What is the difference between the highest and the second highest Area (% of total land area) in 1964?
Your response must be concise. 2.17. What is the difference between the highest and the lowest Area (% of total land area) in 1961?
Provide a succinct answer. 14.49. What is the difference between the highest and the lowest Area (% of total land area) of 1962?
Your answer should be very brief. 14.01. What is the difference between the highest and the lowest Area (% of total land area) in 1963?
Provide a short and direct response. 13.58. What is the difference between the highest and the lowest Area (% of total land area) of 1964?
Make the answer very short. 13.16. 